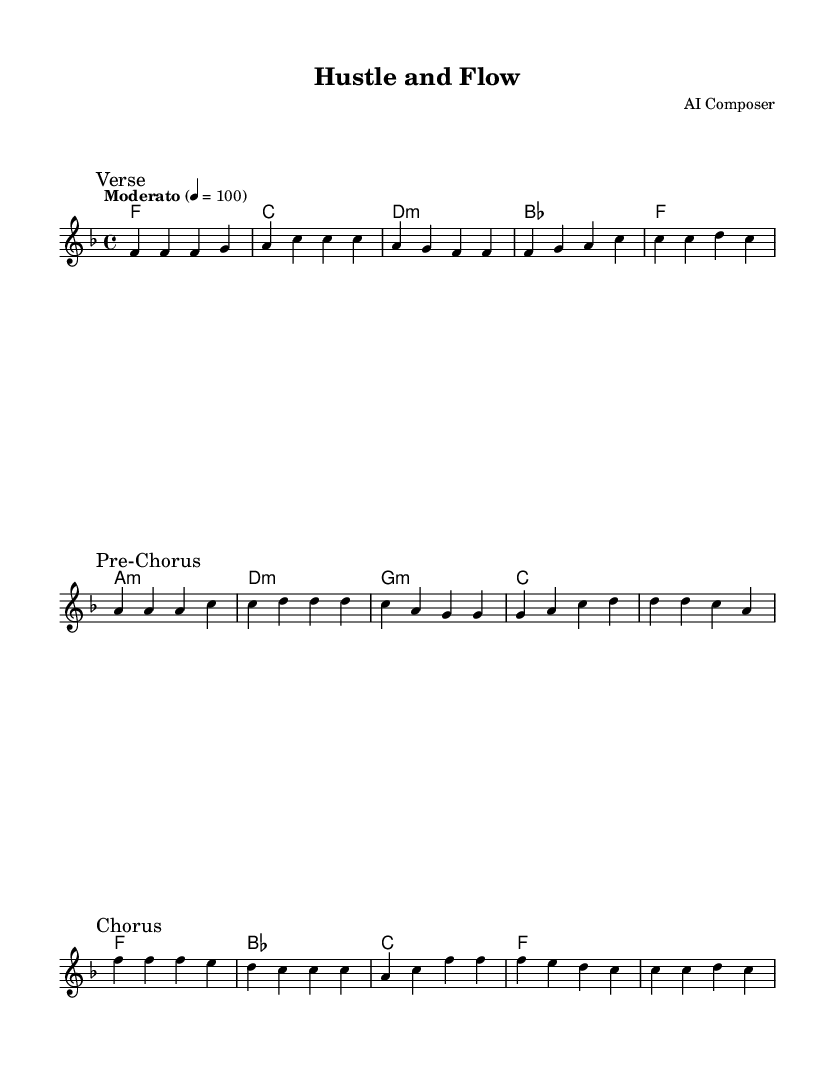What is the key signature of this music? The key signature is F major, which has one flat (B flat). This can be identified at the beginning of the music sheet where the key signature is notated.
Answer: F major What is the time signature of this music? The time signature is 4/4, indicated at the beginning of the score. This means there are four beats in a measure, and the quarter note gets one beat.
Answer: 4/4 What is the tempo marking of this piece? The tempo marking is "Moderato," which indicates a moderate speed for the music, and is set to a metronome marking of 100 beats per minute. This is shown at the start of the score.
Answer: Moderato Which chord is played in the first measure? The chord in the first measure is F major. This can be seen in the chord symbols written above the staff where the first chord is labeled as F.
Answer: F How many sections are there in this piece? The piece consists of three sections: Verse, Pre-Chorus, and Chorus, which are clearly marked in the music notation. These sections are delineated with the respective markings.
Answer: three What is the predominant emotion conveyed by the harmony in this piece? The harmony primarily resolves to the F major chord, establishing a sense of stability and positivity, which is often associated with the motivational aspects of R&B. This can be deduced from the repeated use of the F major chord throughout the score.
Answer: positivity 